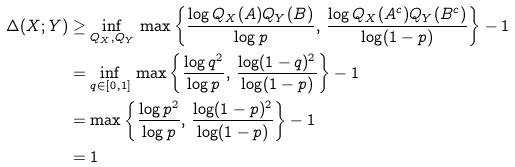Convert formula to latex. <formula><loc_0><loc_0><loc_500><loc_500>\Delta ( X ; Y ) & \geq \inf _ { Q _ { X } , Q _ { Y } } \, \max \left \{ \frac { \log Q _ { X } ( A ) Q _ { Y } ( B ) } { \log p } , \, \frac { \log Q _ { X } ( A ^ { c } ) Q _ { Y } ( B ^ { c } ) } { \log ( 1 - p ) } \right \} - 1 \\ & = \inf _ { q \in [ 0 , 1 ] } \, \max \left \{ \frac { \log q ^ { 2 } } { \log p } , \, \frac { \log ( 1 - q ) ^ { 2 } } { \log ( 1 - p ) } \right \} - 1 \\ & = \max \left \{ \frac { \log p ^ { 2 } } { \log p } , \, \frac { \log ( 1 - p ) ^ { 2 } } { \log ( 1 - p ) } \right \} - 1 \\ & = 1</formula> 